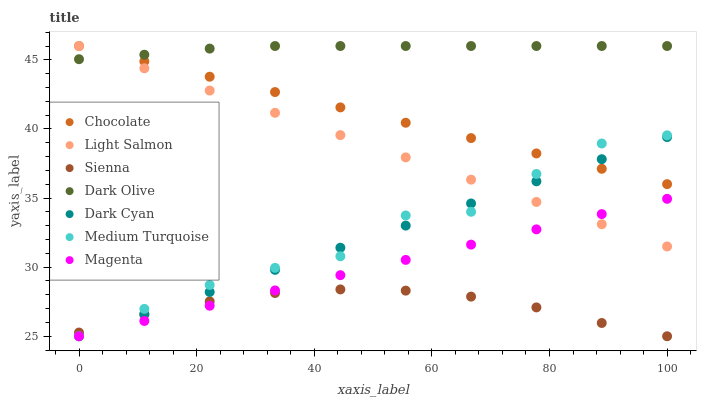Does Sienna have the minimum area under the curve?
Answer yes or no. Yes. Does Dark Olive have the maximum area under the curve?
Answer yes or no. Yes. Does Chocolate have the minimum area under the curve?
Answer yes or no. No. Does Chocolate have the maximum area under the curve?
Answer yes or no. No. Is Light Salmon the smoothest?
Answer yes or no. Yes. Is Medium Turquoise the roughest?
Answer yes or no. Yes. Is Dark Olive the smoothest?
Answer yes or no. No. Is Dark Olive the roughest?
Answer yes or no. No. Does Sienna have the lowest value?
Answer yes or no. Yes. Does Chocolate have the lowest value?
Answer yes or no. No. Does Chocolate have the highest value?
Answer yes or no. Yes. Does Sienna have the highest value?
Answer yes or no. No. Is Magenta less than Dark Olive?
Answer yes or no. Yes. Is Chocolate greater than Magenta?
Answer yes or no. Yes. Does Medium Turquoise intersect Magenta?
Answer yes or no. Yes. Is Medium Turquoise less than Magenta?
Answer yes or no. No. Is Medium Turquoise greater than Magenta?
Answer yes or no. No. Does Magenta intersect Dark Olive?
Answer yes or no. No. 